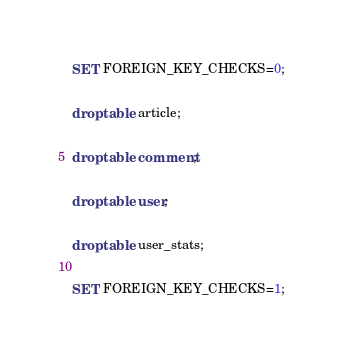Convert code to text. <code><loc_0><loc_0><loc_500><loc_500><_SQL_>SET FOREIGN_KEY_CHECKS=0;

drop table article;

drop table comment;

drop table user;

drop table user_stats;

SET FOREIGN_KEY_CHECKS=1;

</code> 